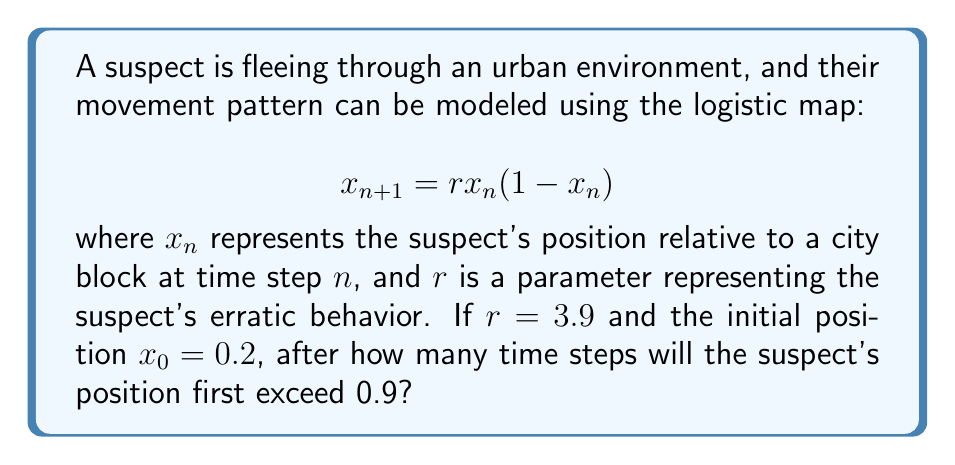Solve this math problem. To solve this problem, we need to iterate the logistic map equation until we find a value of $x_n$ that exceeds 0.9. Let's go through this step-by-step:

1) First, we set up our initial conditions:
   $r = 3.9$
   $x_0 = 0.2$

2) Now, we iterate the map:

   For $n = 1$:
   $x_1 = 3.9 * 0.2 * (1 - 0.2) = 0.624$

   For $n = 2$:
   $x_2 = 3.9 * 0.624 * (1 - 0.624) = 0.915024$

3) We can see that $x_2 > 0.9$, so we stop here.

Therefore, it takes 2 time steps for the suspect's position to first exceed 0.9.

Note: This example demonstrates the sensitivity to initial conditions characteristic of chaotic systems. Small changes in the initial position or the parameter $r$ can lead to dramatically different outcomes, making long-term prediction of the suspect's movement difficult - a hallmark of chaos theory.
Answer: 2 time steps 